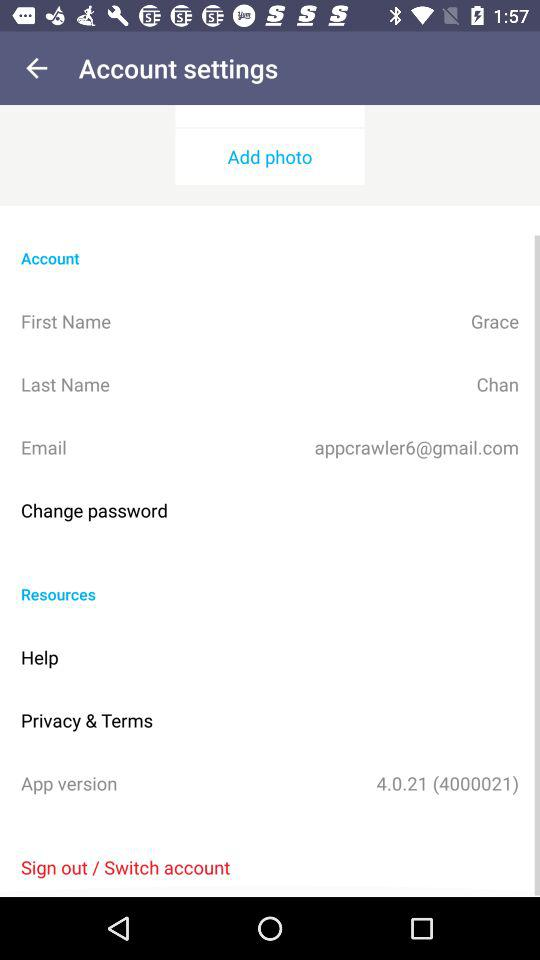What is the last name? The last name is Chan. 